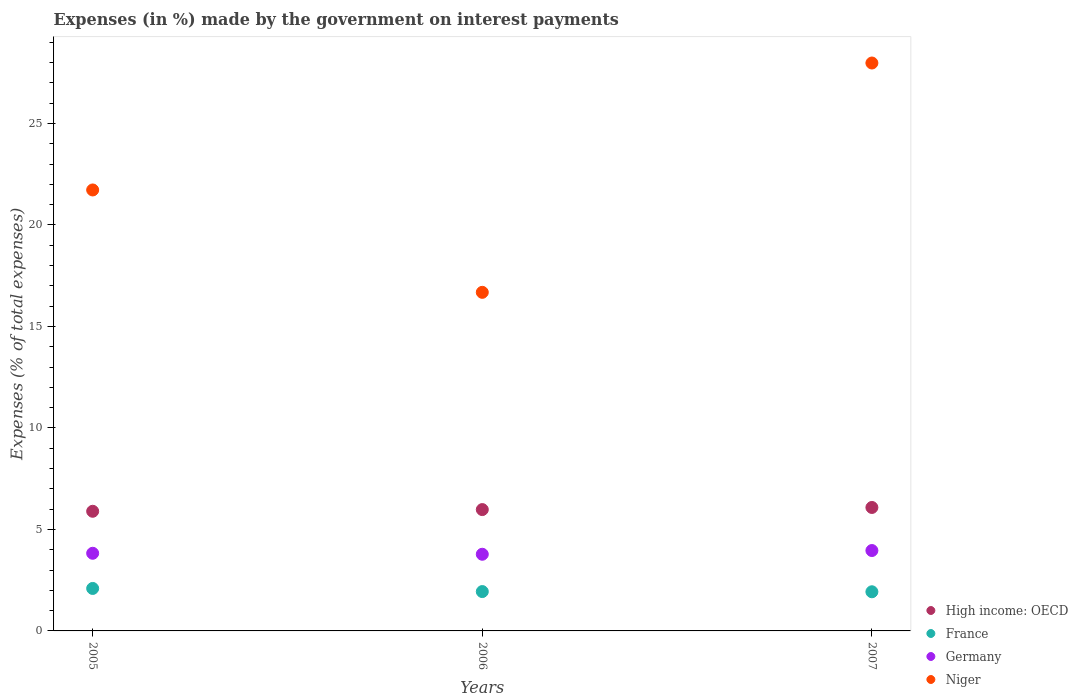What is the percentage of expenses made by the government on interest payments in Niger in 2007?
Offer a very short reply. 27.98. Across all years, what is the maximum percentage of expenses made by the government on interest payments in France?
Keep it short and to the point. 2.09. Across all years, what is the minimum percentage of expenses made by the government on interest payments in High income: OECD?
Give a very brief answer. 5.89. In which year was the percentage of expenses made by the government on interest payments in High income: OECD maximum?
Offer a very short reply. 2007. What is the total percentage of expenses made by the government on interest payments in France in the graph?
Ensure brevity in your answer.  5.96. What is the difference between the percentage of expenses made by the government on interest payments in Germany in 2005 and that in 2006?
Make the answer very short. 0.05. What is the difference between the percentage of expenses made by the government on interest payments in France in 2006 and the percentage of expenses made by the government on interest payments in Niger in 2005?
Provide a succinct answer. -19.78. What is the average percentage of expenses made by the government on interest payments in France per year?
Offer a terse response. 1.99. In the year 2005, what is the difference between the percentage of expenses made by the government on interest payments in High income: OECD and percentage of expenses made by the government on interest payments in Germany?
Your answer should be compact. 2.07. What is the ratio of the percentage of expenses made by the government on interest payments in Germany in 2005 to that in 2006?
Your response must be concise. 1.01. Is the percentage of expenses made by the government on interest payments in Niger in 2005 less than that in 2007?
Give a very brief answer. Yes. Is the difference between the percentage of expenses made by the government on interest payments in High income: OECD in 2006 and 2007 greater than the difference between the percentage of expenses made by the government on interest payments in Germany in 2006 and 2007?
Offer a very short reply. Yes. What is the difference between the highest and the second highest percentage of expenses made by the government on interest payments in France?
Your answer should be compact. 0.15. What is the difference between the highest and the lowest percentage of expenses made by the government on interest payments in Germany?
Give a very brief answer. 0.18. Is the sum of the percentage of expenses made by the government on interest payments in High income: OECD in 2005 and 2007 greater than the maximum percentage of expenses made by the government on interest payments in Germany across all years?
Ensure brevity in your answer.  Yes. Is it the case that in every year, the sum of the percentage of expenses made by the government on interest payments in Niger and percentage of expenses made by the government on interest payments in High income: OECD  is greater than the sum of percentage of expenses made by the government on interest payments in Germany and percentage of expenses made by the government on interest payments in France?
Keep it short and to the point. Yes. Does the percentage of expenses made by the government on interest payments in Niger monotonically increase over the years?
Your answer should be very brief. No. Is the percentage of expenses made by the government on interest payments in France strictly greater than the percentage of expenses made by the government on interest payments in Niger over the years?
Offer a very short reply. No. Where does the legend appear in the graph?
Offer a terse response. Bottom right. How are the legend labels stacked?
Give a very brief answer. Vertical. What is the title of the graph?
Offer a terse response. Expenses (in %) made by the government on interest payments. Does "Sudan" appear as one of the legend labels in the graph?
Give a very brief answer. No. What is the label or title of the X-axis?
Provide a short and direct response. Years. What is the label or title of the Y-axis?
Provide a short and direct response. Expenses (% of total expenses). What is the Expenses (% of total expenses) of High income: OECD in 2005?
Give a very brief answer. 5.89. What is the Expenses (% of total expenses) in France in 2005?
Your answer should be compact. 2.09. What is the Expenses (% of total expenses) in Germany in 2005?
Provide a short and direct response. 3.83. What is the Expenses (% of total expenses) of Niger in 2005?
Provide a short and direct response. 21.72. What is the Expenses (% of total expenses) of High income: OECD in 2006?
Offer a very short reply. 5.98. What is the Expenses (% of total expenses) of France in 2006?
Your answer should be very brief. 1.94. What is the Expenses (% of total expenses) of Germany in 2006?
Your answer should be very brief. 3.78. What is the Expenses (% of total expenses) in Niger in 2006?
Keep it short and to the point. 16.68. What is the Expenses (% of total expenses) in High income: OECD in 2007?
Offer a very short reply. 6.08. What is the Expenses (% of total expenses) of France in 2007?
Your answer should be compact. 1.93. What is the Expenses (% of total expenses) in Germany in 2007?
Offer a terse response. 3.96. What is the Expenses (% of total expenses) of Niger in 2007?
Your answer should be compact. 27.98. Across all years, what is the maximum Expenses (% of total expenses) in High income: OECD?
Offer a terse response. 6.08. Across all years, what is the maximum Expenses (% of total expenses) of France?
Your answer should be very brief. 2.09. Across all years, what is the maximum Expenses (% of total expenses) in Germany?
Ensure brevity in your answer.  3.96. Across all years, what is the maximum Expenses (% of total expenses) in Niger?
Provide a succinct answer. 27.98. Across all years, what is the minimum Expenses (% of total expenses) of High income: OECD?
Offer a terse response. 5.89. Across all years, what is the minimum Expenses (% of total expenses) of France?
Offer a very short reply. 1.93. Across all years, what is the minimum Expenses (% of total expenses) of Germany?
Your response must be concise. 3.78. Across all years, what is the minimum Expenses (% of total expenses) of Niger?
Offer a terse response. 16.68. What is the total Expenses (% of total expenses) of High income: OECD in the graph?
Your answer should be compact. 17.95. What is the total Expenses (% of total expenses) in France in the graph?
Offer a terse response. 5.96. What is the total Expenses (% of total expenses) in Germany in the graph?
Make the answer very short. 11.56. What is the total Expenses (% of total expenses) of Niger in the graph?
Make the answer very short. 66.38. What is the difference between the Expenses (% of total expenses) of High income: OECD in 2005 and that in 2006?
Make the answer very short. -0.08. What is the difference between the Expenses (% of total expenses) in France in 2005 and that in 2006?
Provide a succinct answer. 0.15. What is the difference between the Expenses (% of total expenses) in Germany in 2005 and that in 2006?
Keep it short and to the point. 0.05. What is the difference between the Expenses (% of total expenses) of Niger in 2005 and that in 2006?
Provide a succinct answer. 5.04. What is the difference between the Expenses (% of total expenses) in High income: OECD in 2005 and that in 2007?
Ensure brevity in your answer.  -0.19. What is the difference between the Expenses (% of total expenses) in France in 2005 and that in 2007?
Ensure brevity in your answer.  0.16. What is the difference between the Expenses (% of total expenses) of Germany in 2005 and that in 2007?
Offer a very short reply. -0.14. What is the difference between the Expenses (% of total expenses) of Niger in 2005 and that in 2007?
Keep it short and to the point. -6.25. What is the difference between the Expenses (% of total expenses) of High income: OECD in 2006 and that in 2007?
Ensure brevity in your answer.  -0.1. What is the difference between the Expenses (% of total expenses) in France in 2006 and that in 2007?
Give a very brief answer. 0.01. What is the difference between the Expenses (% of total expenses) in Germany in 2006 and that in 2007?
Make the answer very short. -0.18. What is the difference between the Expenses (% of total expenses) in Niger in 2006 and that in 2007?
Provide a succinct answer. -11.3. What is the difference between the Expenses (% of total expenses) in High income: OECD in 2005 and the Expenses (% of total expenses) in France in 2006?
Give a very brief answer. 3.96. What is the difference between the Expenses (% of total expenses) in High income: OECD in 2005 and the Expenses (% of total expenses) in Germany in 2006?
Offer a very short reply. 2.12. What is the difference between the Expenses (% of total expenses) of High income: OECD in 2005 and the Expenses (% of total expenses) of Niger in 2006?
Give a very brief answer. -10.79. What is the difference between the Expenses (% of total expenses) in France in 2005 and the Expenses (% of total expenses) in Germany in 2006?
Give a very brief answer. -1.68. What is the difference between the Expenses (% of total expenses) in France in 2005 and the Expenses (% of total expenses) in Niger in 2006?
Make the answer very short. -14.59. What is the difference between the Expenses (% of total expenses) in Germany in 2005 and the Expenses (% of total expenses) in Niger in 2006?
Offer a terse response. -12.86. What is the difference between the Expenses (% of total expenses) of High income: OECD in 2005 and the Expenses (% of total expenses) of France in 2007?
Give a very brief answer. 3.97. What is the difference between the Expenses (% of total expenses) of High income: OECD in 2005 and the Expenses (% of total expenses) of Germany in 2007?
Your answer should be very brief. 1.93. What is the difference between the Expenses (% of total expenses) in High income: OECD in 2005 and the Expenses (% of total expenses) in Niger in 2007?
Provide a short and direct response. -22.08. What is the difference between the Expenses (% of total expenses) of France in 2005 and the Expenses (% of total expenses) of Germany in 2007?
Your answer should be very brief. -1.87. What is the difference between the Expenses (% of total expenses) in France in 2005 and the Expenses (% of total expenses) in Niger in 2007?
Your response must be concise. -25.88. What is the difference between the Expenses (% of total expenses) of Germany in 2005 and the Expenses (% of total expenses) of Niger in 2007?
Provide a succinct answer. -24.15. What is the difference between the Expenses (% of total expenses) of High income: OECD in 2006 and the Expenses (% of total expenses) of France in 2007?
Offer a very short reply. 4.05. What is the difference between the Expenses (% of total expenses) in High income: OECD in 2006 and the Expenses (% of total expenses) in Germany in 2007?
Provide a succinct answer. 2.02. What is the difference between the Expenses (% of total expenses) in High income: OECD in 2006 and the Expenses (% of total expenses) in Niger in 2007?
Ensure brevity in your answer.  -22. What is the difference between the Expenses (% of total expenses) in France in 2006 and the Expenses (% of total expenses) in Germany in 2007?
Offer a terse response. -2.02. What is the difference between the Expenses (% of total expenses) in France in 2006 and the Expenses (% of total expenses) in Niger in 2007?
Your response must be concise. -26.04. What is the difference between the Expenses (% of total expenses) in Germany in 2006 and the Expenses (% of total expenses) in Niger in 2007?
Offer a very short reply. -24.2. What is the average Expenses (% of total expenses) in High income: OECD per year?
Your response must be concise. 5.98. What is the average Expenses (% of total expenses) in France per year?
Make the answer very short. 1.99. What is the average Expenses (% of total expenses) in Germany per year?
Provide a succinct answer. 3.85. What is the average Expenses (% of total expenses) in Niger per year?
Offer a very short reply. 22.13. In the year 2005, what is the difference between the Expenses (% of total expenses) in High income: OECD and Expenses (% of total expenses) in France?
Ensure brevity in your answer.  3.8. In the year 2005, what is the difference between the Expenses (% of total expenses) in High income: OECD and Expenses (% of total expenses) in Germany?
Keep it short and to the point. 2.07. In the year 2005, what is the difference between the Expenses (% of total expenses) in High income: OECD and Expenses (% of total expenses) in Niger?
Provide a short and direct response. -15.83. In the year 2005, what is the difference between the Expenses (% of total expenses) of France and Expenses (% of total expenses) of Germany?
Provide a short and direct response. -1.73. In the year 2005, what is the difference between the Expenses (% of total expenses) in France and Expenses (% of total expenses) in Niger?
Give a very brief answer. -19.63. In the year 2005, what is the difference between the Expenses (% of total expenses) of Germany and Expenses (% of total expenses) of Niger?
Provide a short and direct response. -17.9. In the year 2006, what is the difference between the Expenses (% of total expenses) of High income: OECD and Expenses (% of total expenses) of France?
Keep it short and to the point. 4.04. In the year 2006, what is the difference between the Expenses (% of total expenses) in High income: OECD and Expenses (% of total expenses) in Germany?
Your answer should be compact. 2.2. In the year 2006, what is the difference between the Expenses (% of total expenses) of High income: OECD and Expenses (% of total expenses) of Niger?
Your response must be concise. -10.7. In the year 2006, what is the difference between the Expenses (% of total expenses) of France and Expenses (% of total expenses) of Germany?
Provide a short and direct response. -1.84. In the year 2006, what is the difference between the Expenses (% of total expenses) in France and Expenses (% of total expenses) in Niger?
Ensure brevity in your answer.  -14.74. In the year 2006, what is the difference between the Expenses (% of total expenses) of Germany and Expenses (% of total expenses) of Niger?
Offer a terse response. -12.9. In the year 2007, what is the difference between the Expenses (% of total expenses) of High income: OECD and Expenses (% of total expenses) of France?
Ensure brevity in your answer.  4.15. In the year 2007, what is the difference between the Expenses (% of total expenses) in High income: OECD and Expenses (% of total expenses) in Germany?
Your answer should be compact. 2.12. In the year 2007, what is the difference between the Expenses (% of total expenses) in High income: OECD and Expenses (% of total expenses) in Niger?
Provide a short and direct response. -21.9. In the year 2007, what is the difference between the Expenses (% of total expenses) of France and Expenses (% of total expenses) of Germany?
Your answer should be compact. -2.03. In the year 2007, what is the difference between the Expenses (% of total expenses) in France and Expenses (% of total expenses) in Niger?
Provide a short and direct response. -26.05. In the year 2007, what is the difference between the Expenses (% of total expenses) of Germany and Expenses (% of total expenses) of Niger?
Your response must be concise. -24.02. What is the ratio of the Expenses (% of total expenses) of France in 2005 to that in 2006?
Your answer should be compact. 1.08. What is the ratio of the Expenses (% of total expenses) of Germany in 2005 to that in 2006?
Your answer should be compact. 1.01. What is the ratio of the Expenses (% of total expenses) of Niger in 2005 to that in 2006?
Offer a very short reply. 1.3. What is the ratio of the Expenses (% of total expenses) in High income: OECD in 2005 to that in 2007?
Make the answer very short. 0.97. What is the ratio of the Expenses (% of total expenses) of France in 2005 to that in 2007?
Give a very brief answer. 1.08. What is the ratio of the Expenses (% of total expenses) of Germany in 2005 to that in 2007?
Ensure brevity in your answer.  0.97. What is the ratio of the Expenses (% of total expenses) of Niger in 2005 to that in 2007?
Make the answer very short. 0.78. What is the ratio of the Expenses (% of total expenses) of High income: OECD in 2006 to that in 2007?
Your response must be concise. 0.98. What is the ratio of the Expenses (% of total expenses) of France in 2006 to that in 2007?
Provide a short and direct response. 1.01. What is the ratio of the Expenses (% of total expenses) of Germany in 2006 to that in 2007?
Give a very brief answer. 0.95. What is the ratio of the Expenses (% of total expenses) in Niger in 2006 to that in 2007?
Offer a terse response. 0.6. What is the difference between the highest and the second highest Expenses (% of total expenses) of High income: OECD?
Keep it short and to the point. 0.1. What is the difference between the highest and the second highest Expenses (% of total expenses) of France?
Your answer should be compact. 0.15. What is the difference between the highest and the second highest Expenses (% of total expenses) in Germany?
Provide a succinct answer. 0.14. What is the difference between the highest and the second highest Expenses (% of total expenses) in Niger?
Give a very brief answer. 6.25. What is the difference between the highest and the lowest Expenses (% of total expenses) of High income: OECD?
Give a very brief answer. 0.19. What is the difference between the highest and the lowest Expenses (% of total expenses) in France?
Offer a very short reply. 0.16. What is the difference between the highest and the lowest Expenses (% of total expenses) in Germany?
Make the answer very short. 0.18. What is the difference between the highest and the lowest Expenses (% of total expenses) of Niger?
Your answer should be compact. 11.3. 